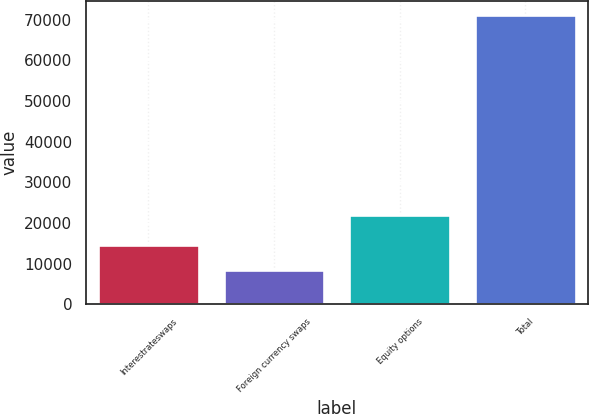Convert chart to OTSL. <chart><loc_0><loc_0><loc_500><loc_500><bar_chart><fcel>Interestrateswaps<fcel>Foreign currency swaps<fcel>Equity options<fcel>Total<nl><fcel>14568.1<fcel>8290<fcel>22007<fcel>71071<nl></chart> 